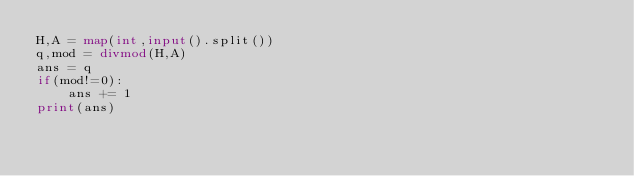<code> <loc_0><loc_0><loc_500><loc_500><_Python_>H,A = map(int,input().split())
q,mod = divmod(H,A)
ans = q
if(mod!=0):
    ans += 1
print(ans)
</code> 